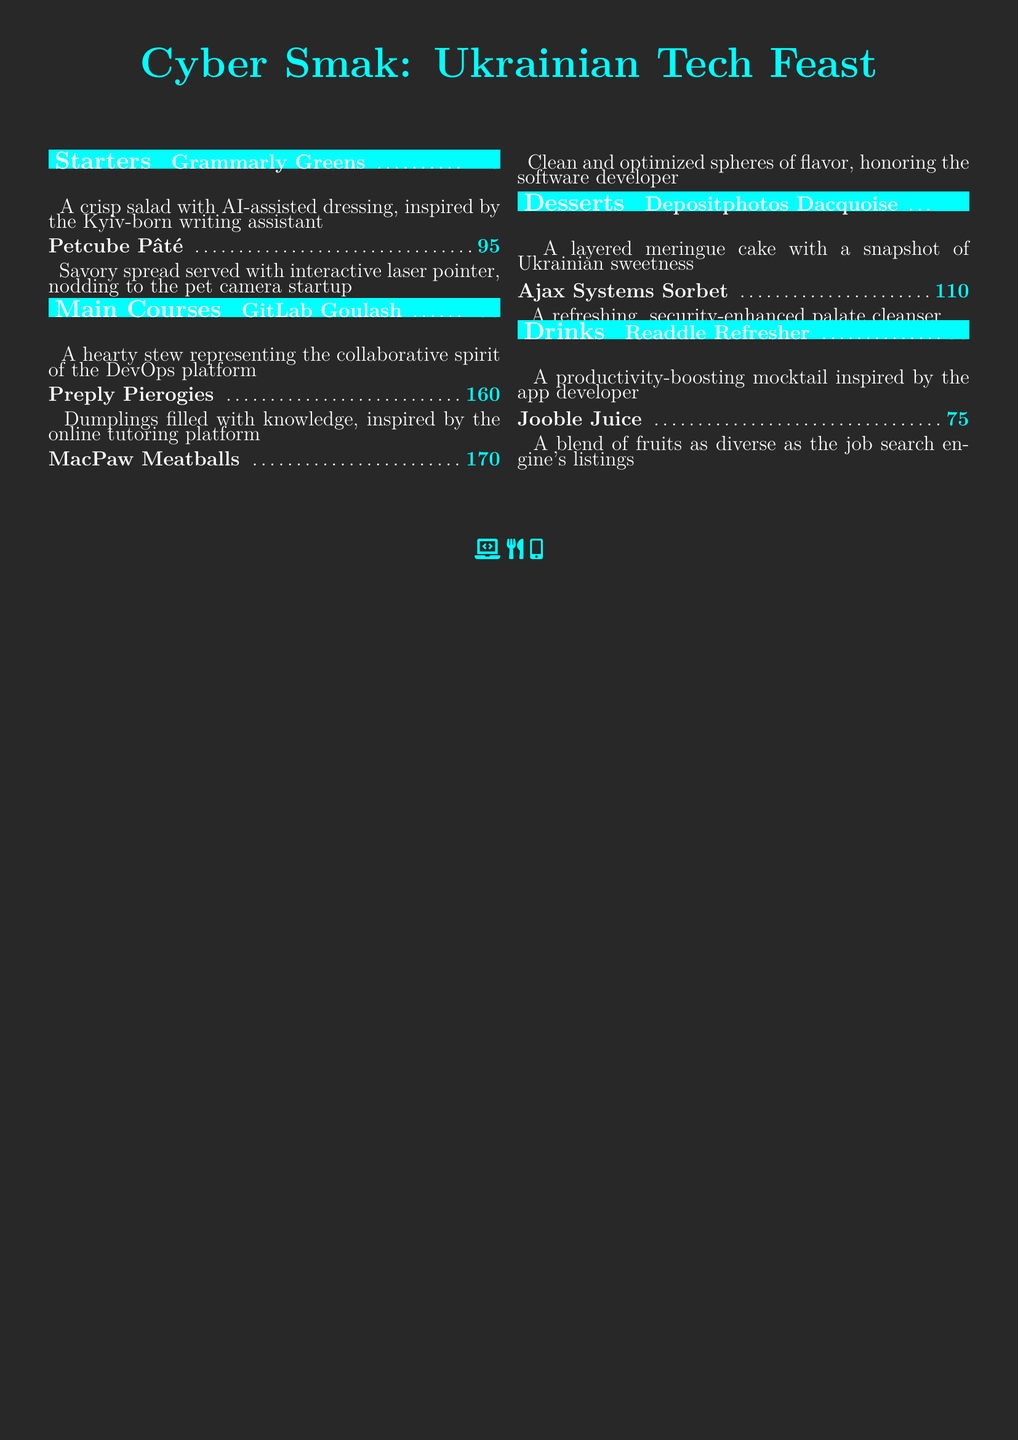What is the price of Grammarly Greens? The price is listed next to the dish name in the menu, specifically for Grammarly Greens.
Answer: ₴120 What dish represents a collaborative spirit? The information about each dish includes descriptions that relate them to their inspirations; the dish that represents collaborative spirit is GitLab Goulash.
Answer: GitLab Goulash Which dessert has a snapshot of sweetness? Each dessert is paired with a description; the dessert that has a snapshot of sweetness is Depositphotos Dacquoise.
Answer: Depositphotos Dacquoise What is the main ingredient of Preply Pierogies? The description of Preply Pierogies highlights that it is filled with knowledge.
Answer: Knowledge How many drinks are listed in the menu? The menu lists the drink section which includes a number of drinks under that category. Counting them provides the answer.
Answer: 2 What is the theme of this menu? The title of the menu explicitly mentions its theme, which is derived from technology and innovation.
Answer: Cyber-themed Which starter includes an interactive laser pointer? Each starter is uniquely described; Petcube Pâté mentions an interactive laser pointer.
Answer: Petcube Pâté What category does Ajax Systems Sorbet belong to? The organization of the menu divides items into categories like Starters, Main Courses, Desserts, and Drinks; Ajax Systems Sorbet belongs to the Desserts category.
Answer: Desserts What is the price of Jooble Juice? The price is indicated next to the drink name within the menu.
Answer: ₴75 